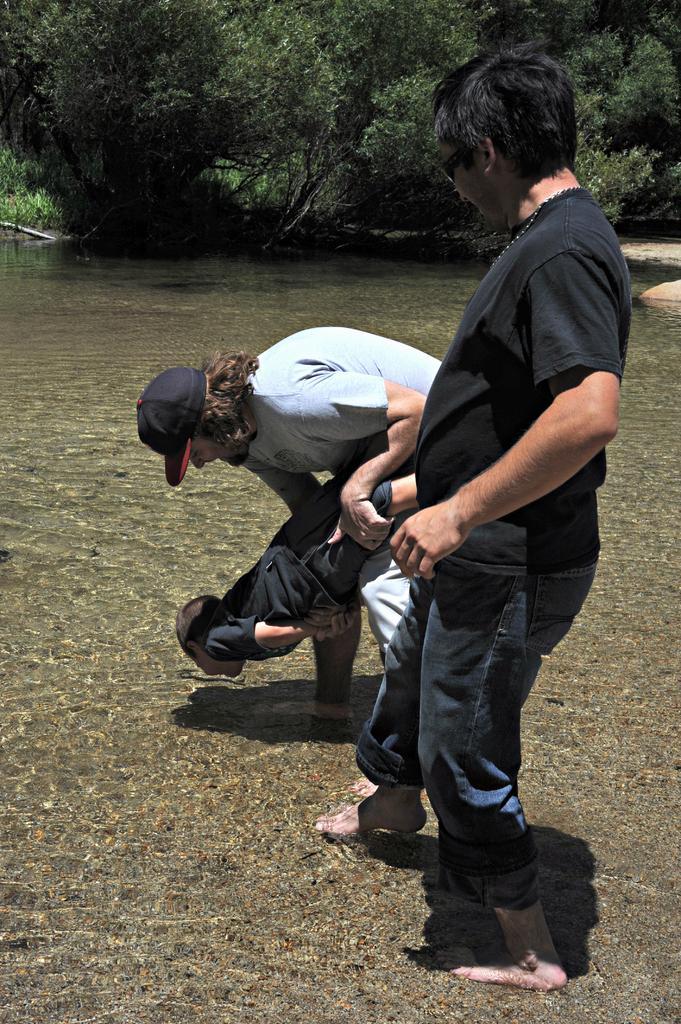In one or two sentences, can you explain what this image depicts? Here we can see two men standing in the water and a person among the two persons is holding a boy in his hands. In the background there are trees and sand. 